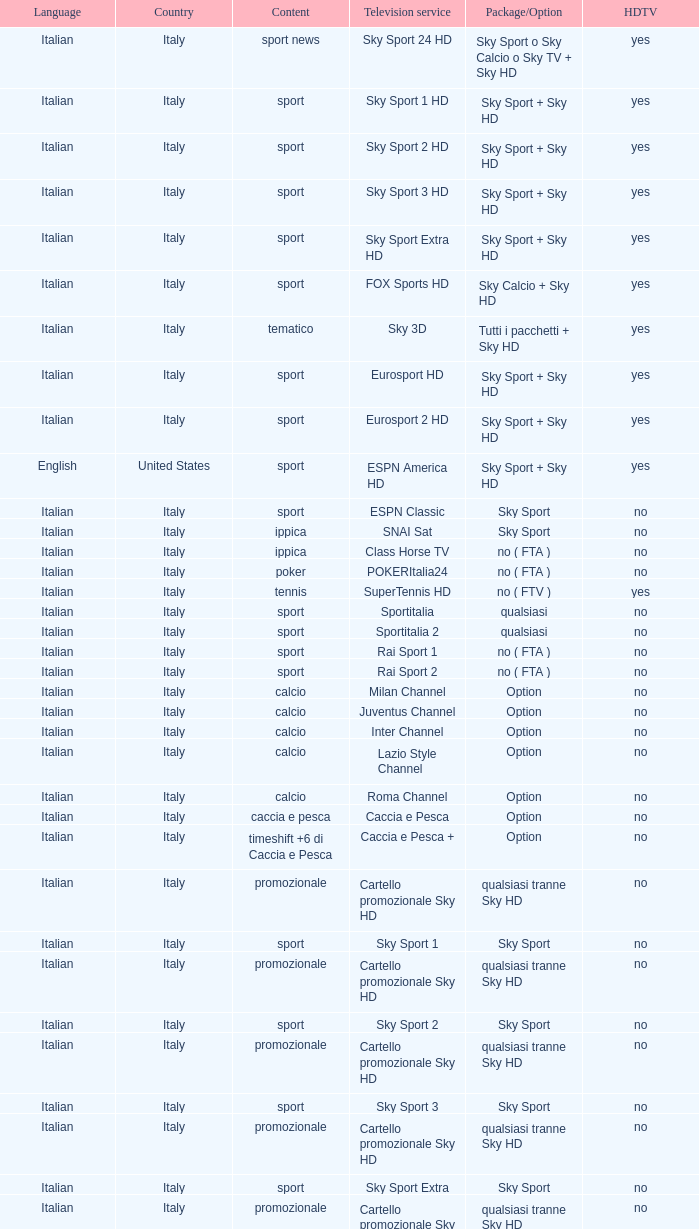What is Package/Option, when Content is Poker? No ( fta ). 